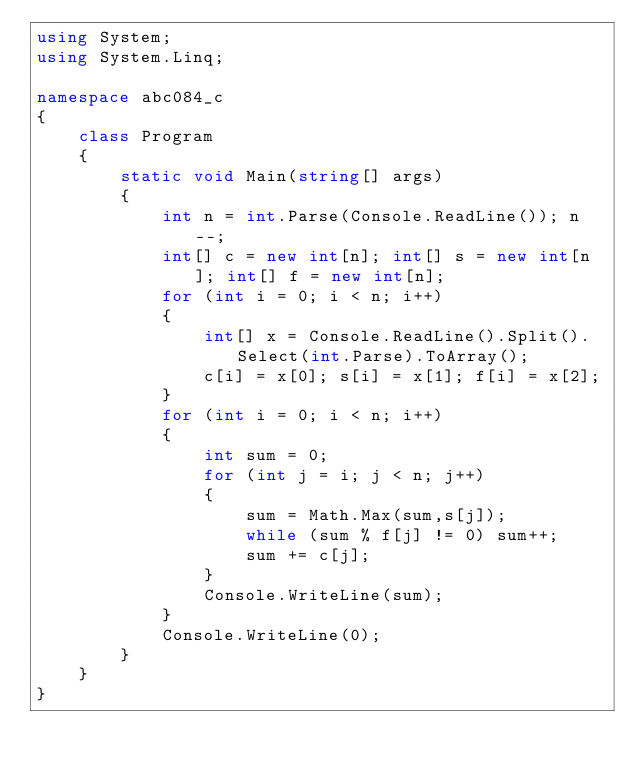Convert code to text. <code><loc_0><loc_0><loc_500><loc_500><_C#_>using System;
using System.Linq;

namespace abc084_c
{
    class Program
    {
        static void Main(string[] args)
        {
            int n = int.Parse(Console.ReadLine()); n--;
            int[] c = new int[n]; int[] s = new int[n]; int[] f = new int[n];
            for (int i = 0; i < n; i++)
            {
                int[] x = Console.ReadLine().Split().Select(int.Parse).ToArray();
                c[i] = x[0]; s[i] = x[1]; f[i] = x[2];
            }
            for (int i = 0; i < n; i++)
            {
                int sum = 0;
                for (int j = i; j < n; j++)
                {
                    sum = Math.Max(sum,s[j]);
                    while (sum % f[j] != 0) sum++;
                    sum += c[j];
                }
                Console.WriteLine(sum);
            }
            Console.WriteLine(0);
        }
    }
}</code> 